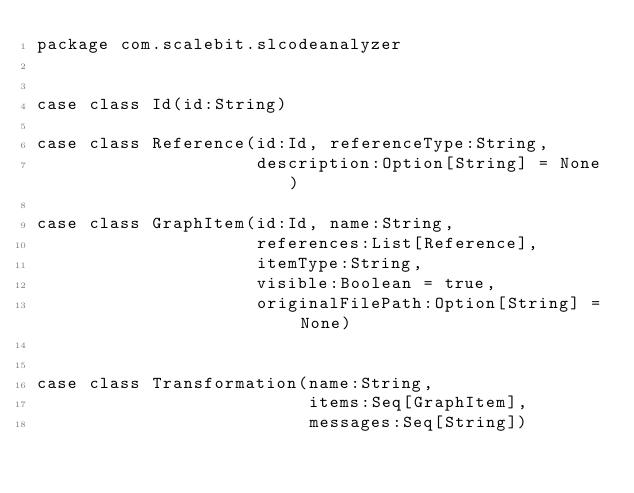<code> <loc_0><loc_0><loc_500><loc_500><_Scala_>package com.scalebit.slcodeanalyzer


case class Id(id:String)

case class Reference(id:Id, referenceType:String,
                     description:Option[String] = None)

case class GraphItem(id:Id, name:String,
                     references:List[Reference],
                     itemType:String,
                     visible:Boolean = true,
                     originalFilePath:Option[String] = None)


case class Transformation(name:String,
                          items:Seq[GraphItem],
                          messages:Seq[String])

</code> 